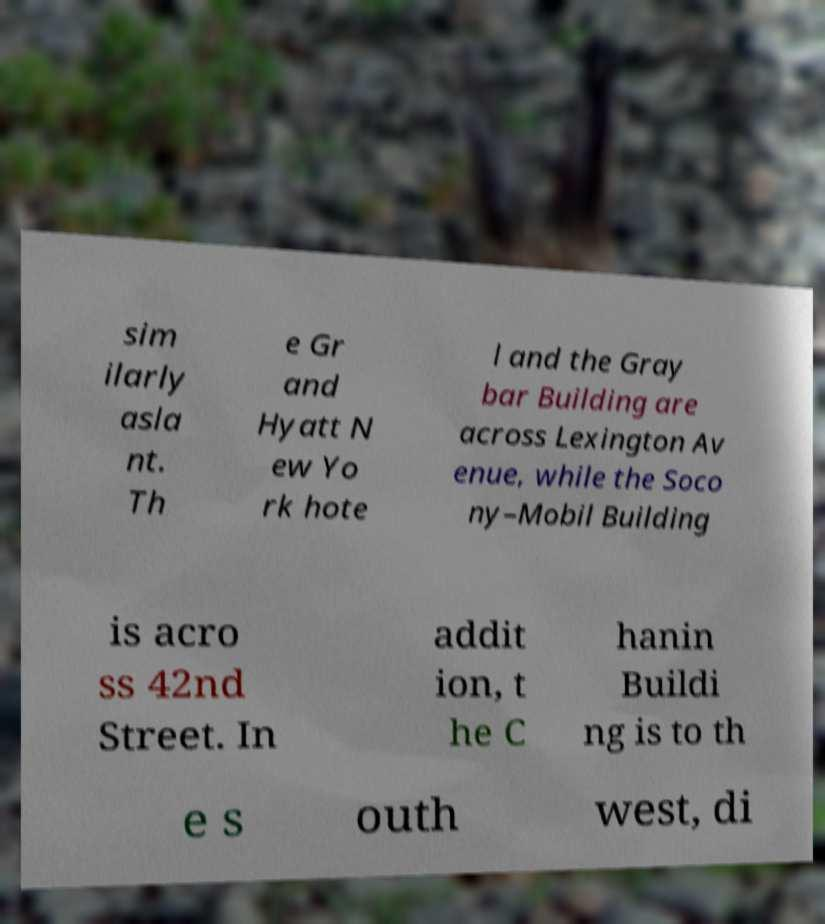I need the written content from this picture converted into text. Can you do that? sim ilarly asla nt. Th e Gr and Hyatt N ew Yo rk hote l and the Gray bar Building are across Lexington Av enue, while the Soco ny–Mobil Building is acro ss 42nd Street. In addit ion, t he C hanin Buildi ng is to th e s outh west, di 